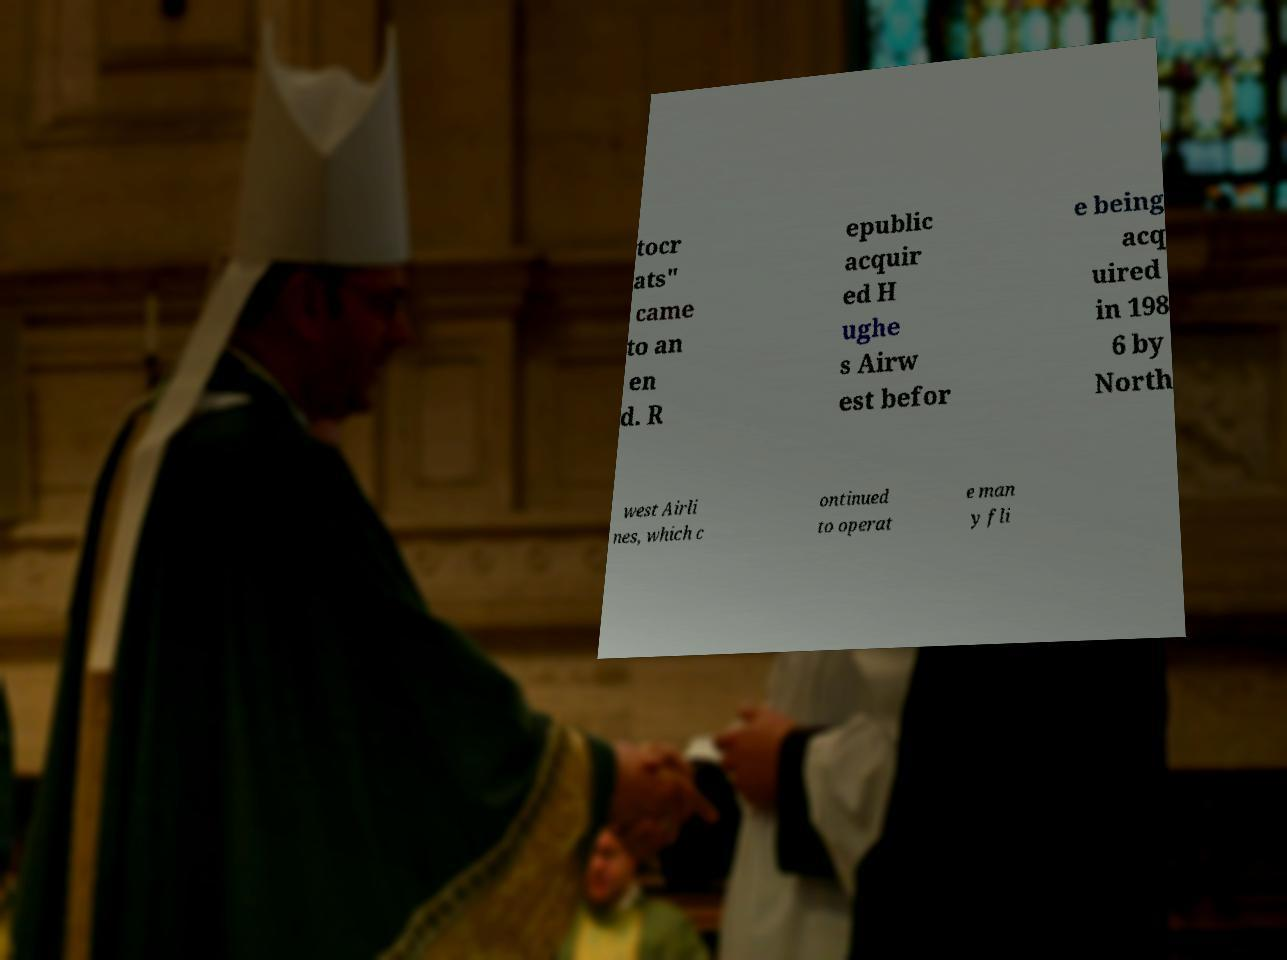Can you read and provide the text displayed in the image?This photo seems to have some interesting text. Can you extract and type it out for me? tocr ats" came to an en d. R epublic acquir ed H ughe s Airw est befor e being acq uired in 198 6 by North west Airli nes, which c ontinued to operat e man y fli 